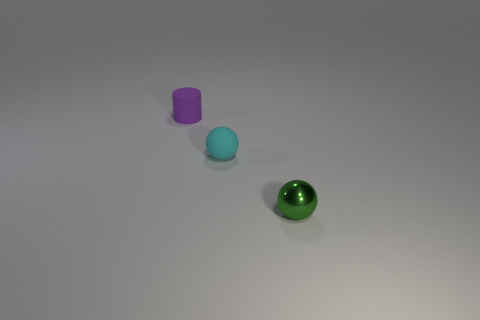What is the color of the other tiny shiny object that is the same shape as the tiny cyan object?
Your response must be concise. Green. Are there the same number of tiny metal things that are on the right side of the tiny green ball and tiny cyan matte balls?
Provide a succinct answer. No. How many cylinders are either small objects or tiny red metallic things?
Your response must be concise. 1. The tiny sphere that is made of the same material as the purple object is what color?
Your answer should be very brief. Cyan. Does the tiny purple cylinder have the same material as the tiny thing that is in front of the small cyan rubber ball?
Offer a very short reply. No. What number of things are matte balls or tiny green cubes?
Provide a short and direct response. 1. Are there any red shiny objects that have the same shape as the cyan rubber thing?
Give a very brief answer. No. There is a small metallic sphere; what number of tiny green metal balls are in front of it?
Ensure brevity in your answer.  0. There is a sphere that is on the right side of the tiny rubber object that is in front of the purple matte cylinder; what is its material?
Your answer should be compact. Metal. There is a green object that is the same size as the purple cylinder; what material is it?
Provide a short and direct response. Metal. 